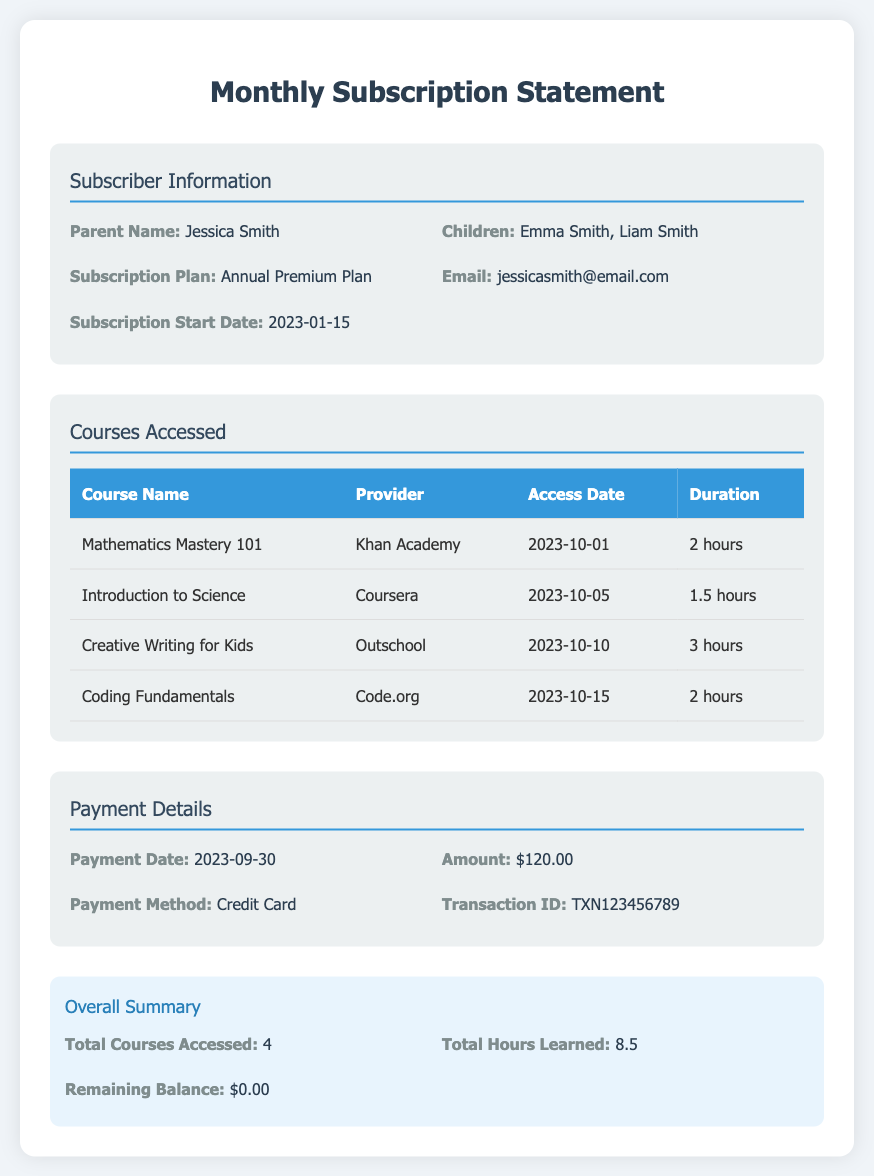What is the name of the parent? The parent's name is provided in the subscriber information section, which is Jessica Smith.
Answer: Jessica Smith What are the names of the children? The document lists the children's names in the subscriber information section as Emma Smith and Liam Smith.
Answer: Emma Smith, Liam Smith What is the subscription plan type? The type of subscription plan is found in the subscriber information section, which indicates the Annual Premium Plan.
Answer: Annual Premium Plan How many courses were accessed? The total number of courses accessed is provided in the overall summary section, which states that 4 courses were accessed.
Answer: 4 What is the total duration of hours learned? The document provides this information in the overall summary section, indicating that the total hours learned are 8.5.
Answer: 8.5 Which course was accessed on October 10, 2023? The specific course accessed on that date is mentioned in the courses accessed section as Creative Writing for Kids.
Answer: Creative Writing for Kids What is the payment amount? The payment amount is detailed in the payment details section, which indicates it is $120.00.
Answer: $120.00 What payment method was used? The payment method is stated in the payment details section as Credit Card.
Answer: Credit Card What is the Transaction ID? The Transaction ID can be found in the payment details section; it is TXN123456789.
Answer: TXN123456789 